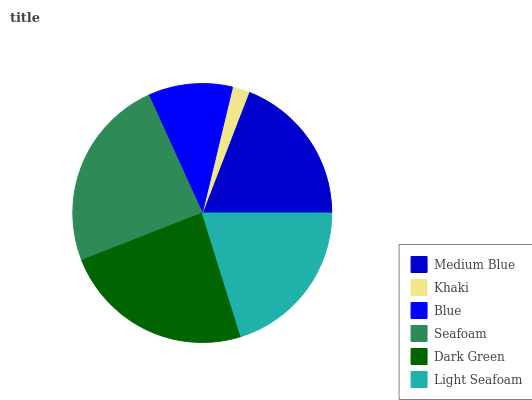Is Khaki the minimum?
Answer yes or no. Yes. Is Seafoam the maximum?
Answer yes or no. Yes. Is Blue the minimum?
Answer yes or no. No. Is Blue the maximum?
Answer yes or no. No. Is Blue greater than Khaki?
Answer yes or no. Yes. Is Khaki less than Blue?
Answer yes or no. Yes. Is Khaki greater than Blue?
Answer yes or no. No. Is Blue less than Khaki?
Answer yes or no. No. Is Light Seafoam the high median?
Answer yes or no. Yes. Is Medium Blue the low median?
Answer yes or no. Yes. Is Khaki the high median?
Answer yes or no. No. Is Dark Green the low median?
Answer yes or no. No. 